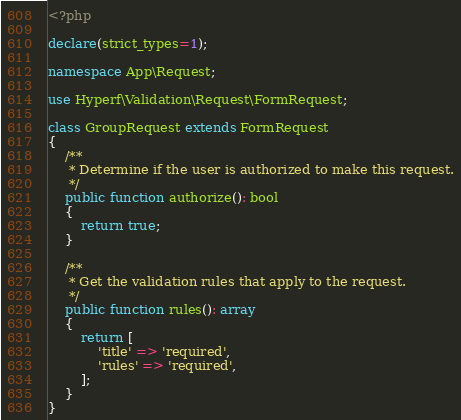Convert code to text. <code><loc_0><loc_0><loc_500><loc_500><_PHP_><?php

declare(strict_types=1);

namespace App\Request;

use Hyperf\Validation\Request\FormRequest;

class GroupRequest extends FormRequest
{
    /**
     * Determine if the user is authorized to make this request.
     */
    public function authorize(): bool
    {
        return true;
    }

    /**
     * Get the validation rules that apply to the request.
     */
    public function rules(): array
    {
        return [
            'title' => 'required',
            'rules' => 'required',
        ];
    }
}
</code> 